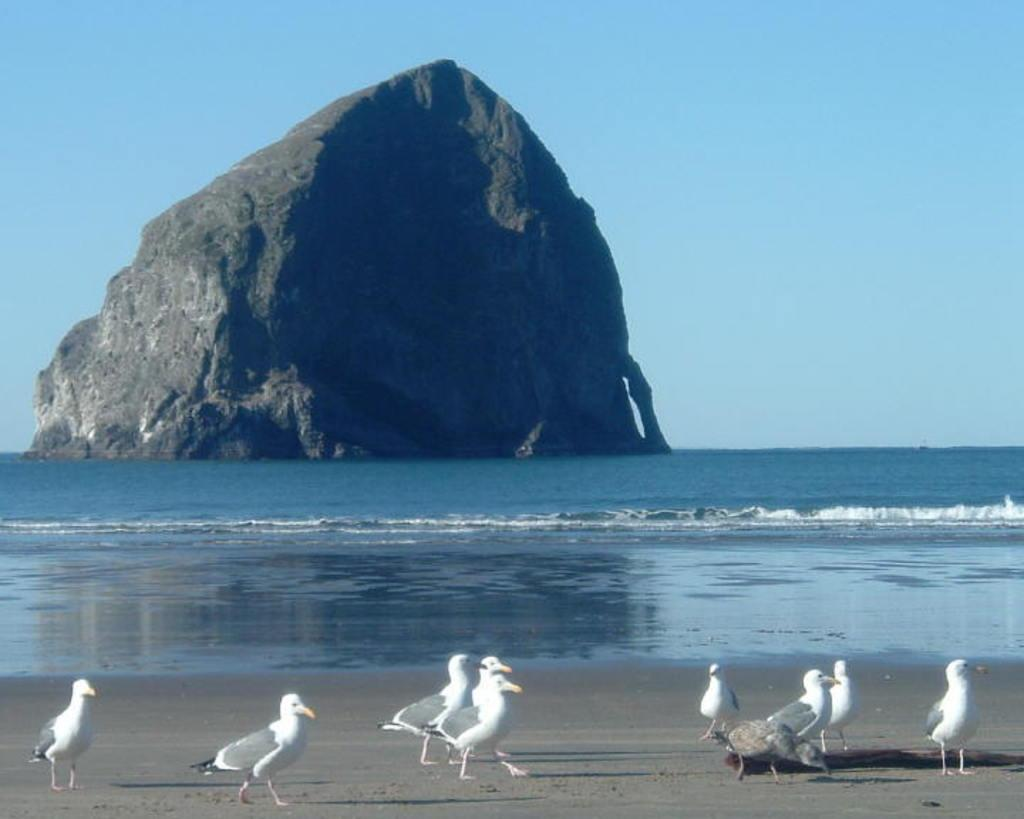What type of birds can be seen in the image? There are white color birds in the image. What is the birds doing in the image? The birds are walking on the sand. What else can be seen in the image besides the birds? There is water visible in the image, a big rock in the middle, and the sky at the top. What type of club can be seen in the image? There is no club present in the image. Can you tell me how many zippers are on the birds in the image? The birds in the image do not have zippers; they are living creatures. 